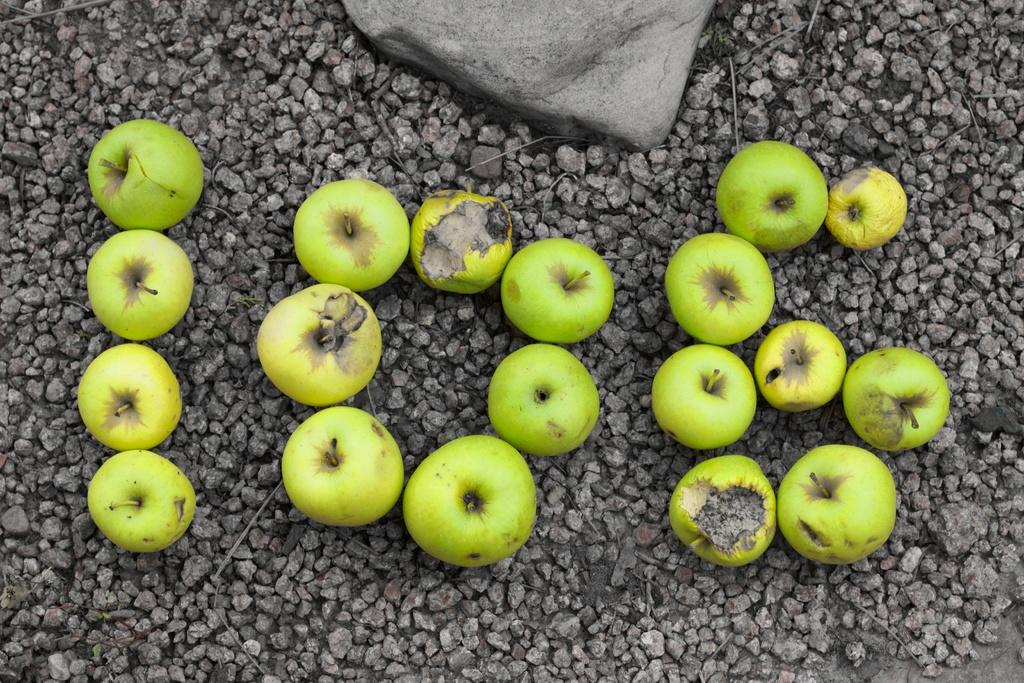What type of fruit is present in the image? There are green apples in the image. What else can be seen on the ground in the image? There are stones on the ground in the image. What type of experience can be gained from eating the green apples in the image? The image does not provide information about the taste or experience of eating the green apples, so it cannot be determined from the image. 